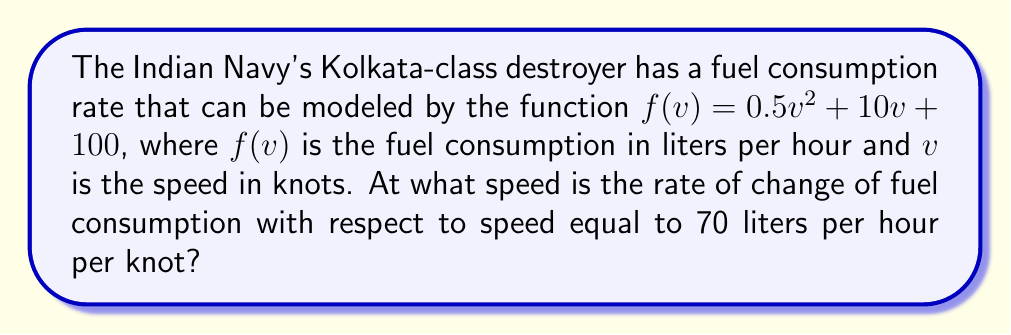Provide a solution to this math problem. To solve this problem, we need to follow these steps:

1) The rate of change of fuel consumption with respect to speed is given by the derivative of $f(v)$.

2) Let's find the derivative of $f(v)$:
   $$f'(v) = \frac{d}{dv}(0.5v^2 + 10v + 100)$$
   $$f'(v) = v + 10$$

3) We want to find the speed at which $f'(v) = 70$. So, let's set up the equation:
   $$v + 10 = 70$$

4) Solve for $v$:
   $$v = 70 - 10$$
   $$v = 60$$

5) Therefore, the rate of change of fuel consumption is 70 liters per hour per knot when the speed is 60 knots.
Answer: 60 knots 